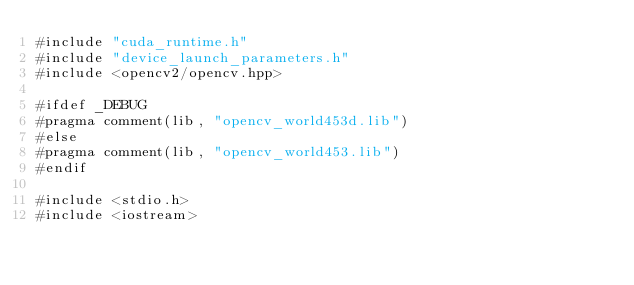Convert code to text. <code><loc_0><loc_0><loc_500><loc_500><_Cuda_>#include "cuda_runtime.h"
#include "device_launch_parameters.h"
#include <opencv2/opencv.hpp>

#ifdef _DEBUG
#pragma comment(lib, "opencv_world453d.lib")
#else
#pragma comment(lib, "opencv_world453.lib")
#endif

#include <stdio.h>
#include <iostream></code> 